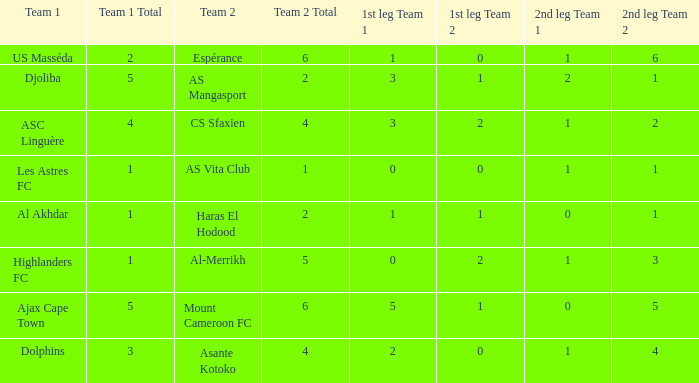What is the team 1 with team 2 Mount Cameroon FC? Ajax Cape Town. 